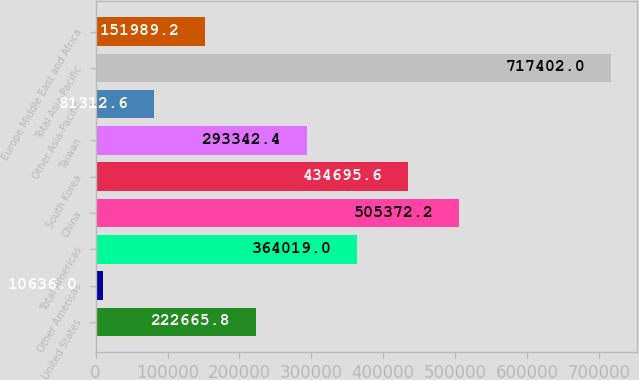Convert chart to OTSL. <chart><loc_0><loc_0><loc_500><loc_500><bar_chart><fcel>United States<fcel>Other Americas<fcel>Total Americas<fcel>China<fcel>South Korea<fcel>Taiwan<fcel>Other Asia-Pacific<fcel>Total Asia-Pacific<fcel>Europe Middle East and Africa<nl><fcel>222666<fcel>10636<fcel>364019<fcel>505372<fcel>434696<fcel>293342<fcel>81312.6<fcel>717402<fcel>151989<nl></chart> 